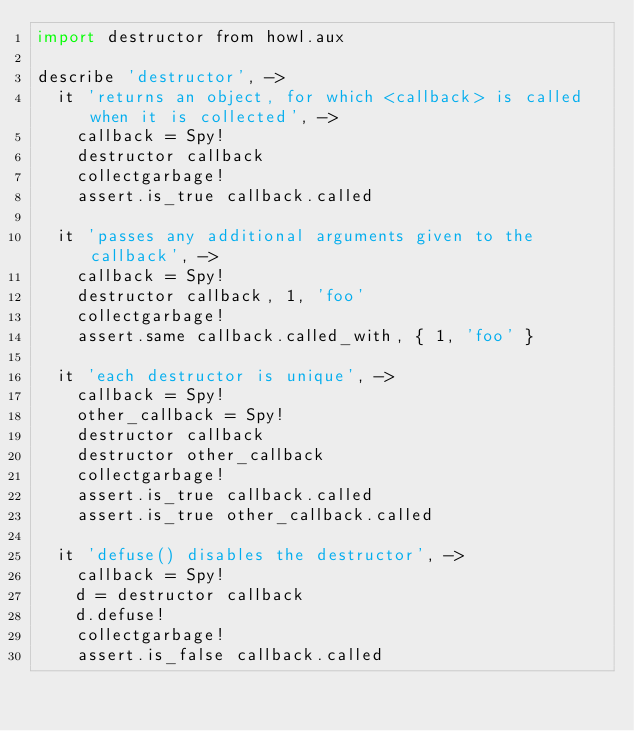Convert code to text. <code><loc_0><loc_0><loc_500><loc_500><_MoonScript_>import destructor from howl.aux

describe 'destructor', ->
  it 'returns an object, for which <callback> is called when it is collected', ->
    callback = Spy!
    destructor callback
    collectgarbage!
    assert.is_true callback.called

  it 'passes any additional arguments given to the callback', ->
    callback = Spy!
    destructor callback, 1, 'foo'
    collectgarbage!
    assert.same callback.called_with, { 1, 'foo' }

  it 'each destructor is unique', ->
    callback = Spy!
    other_callback = Spy!
    destructor callback
    destructor other_callback
    collectgarbage!
    assert.is_true callback.called
    assert.is_true other_callback.called

  it 'defuse() disables the destructor', ->
    callback = Spy!
    d = destructor callback
    d.defuse!
    collectgarbage!
    assert.is_false callback.called
</code> 